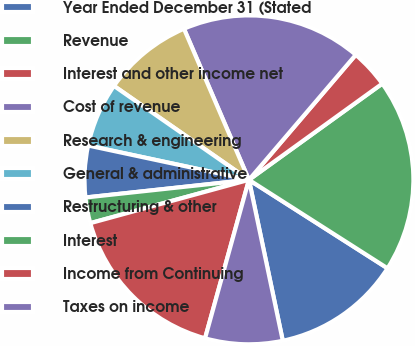<chart> <loc_0><loc_0><loc_500><loc_500><pie_chart><fcel>Year Ended December 31 (Stated<fcel>Revenue<fcel>Interest and other income net<fcel>Cost of revenue<fcel>Research & engineering<fcel>General & administrative<fcel>Restructuring & other<fcel>Interest<fcel>Income from Continuing<fcel>Taxes on income<nl><fcel>12.66%<fcel>18.99%<fcel>3.8%<fcel>17.72%<fcel>8.86%<fcel>6.33%<fcel>5.06%<fcel>2.53%<fcel>16.46%<fcel>7.6%<nl></chart> 